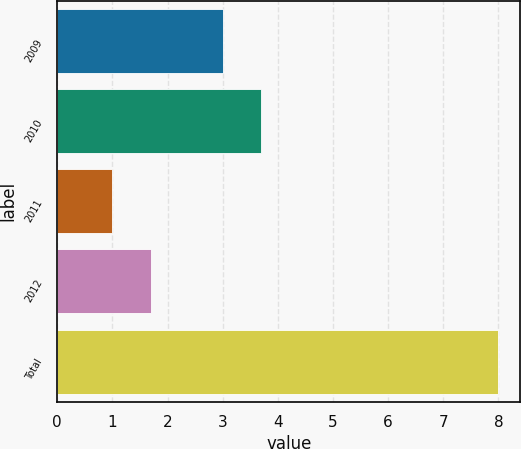Convert chart. <chart><loc_0><loc_0><loc_500><loc_500><bar_chart><fcel>2009<fcel>2010<fcel>2011<fcel>2012<fcel>Total<nl><fcel>3<fcel>3.7<fcel>1<fcel>1.7<fcel>8<nl></chart> 